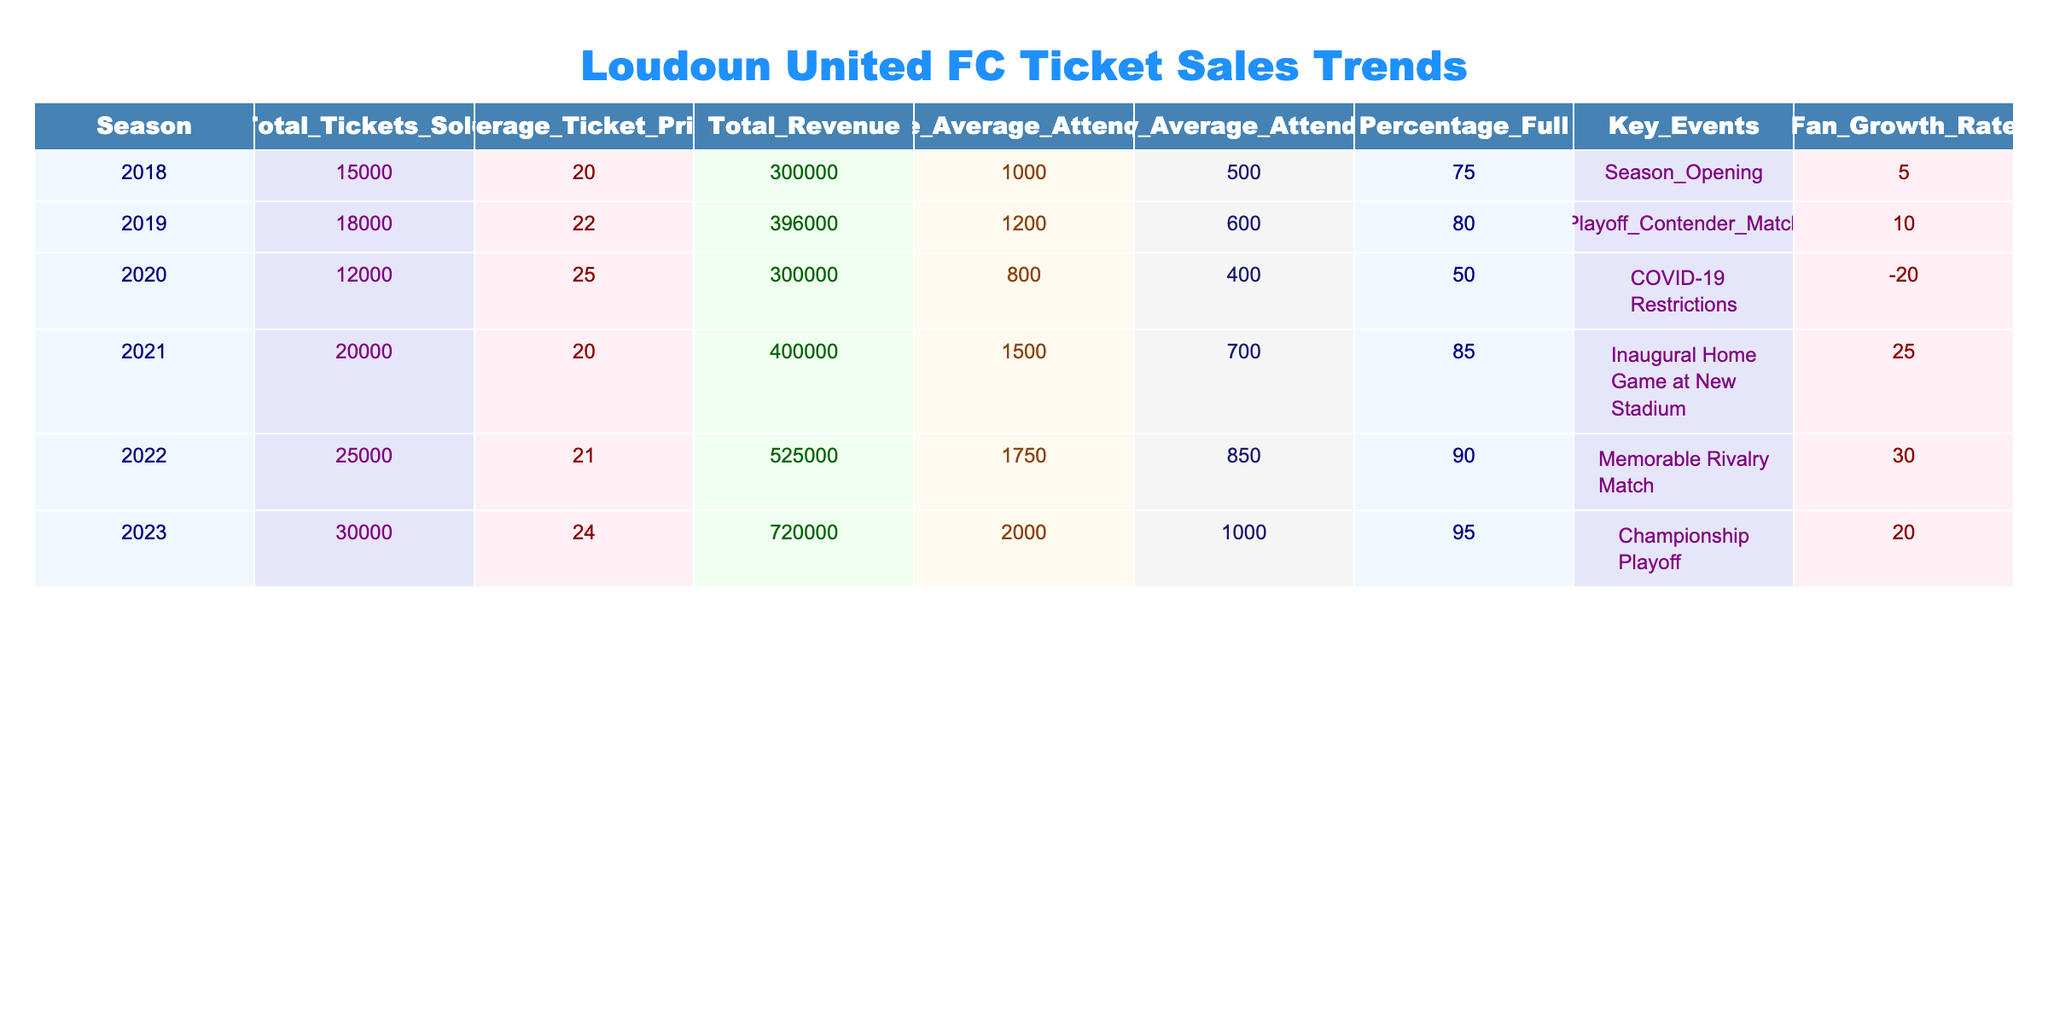What was the total revenue generated in the 2022 season? The total revenue for the 2022 season can be found directly in the table, indicated in the Total_Revenue column for that season. According to the data, the total revenue for 2022 is $525,000.
Answer: 525000 Which season had the highest average ticket price? To identify the season with the highest average ticket price, we need to compare the values in the Average_Ticket_Price column across all seasons. The maximum value is seen in the 2020 season, which is $25.
Answer: 2020 What is the percentage growth rate from the 2018 season to the 2023 season? We need to find the fan growth rate for both the 2018 and 2023 seasons. The growth rate for 2018 is 5, and for 2023 it's 20. To calculate the percentage growth, we subtract the two rates, then divide by the 2018 rate and multiply by 100: (20 - 5) / 5 * 100 = 300%.
Answer: 300% In which season did the average home attendance exceed 1,700? Looking at the Home_Average_Attendance column, we find the seasons where the value exceeds 1,700. Only the 2022 and 2023 seasons have average home attendance above this threshold.
Answer: 2022 and 2023 Did Loudoun United FC see a decline in total ticket sales from 2019 to 2020? By comparing the Total_Tickets_Sold for 2019 (18,000) and 2020 (12,000), we can see that total ticket sales indeed fell from 2019 to 2020, indicating a decline.
Answer: Yes What was the average attendance across all home games for the 2021 season? The Average_Home_Attendance for the 2021 season is directly listed in the table under the Home_Average_Attendance column, which shows that the average attendance was 1,500.
Answer: 1500 What is the total tickets sold for the seasons that had a fan growth rate over 15? We need to identify the seasons with a fan growth rate greater than 15 from the Fan_Growth_Rate column. Those seasons are 2021 (25), 2022 (30), and 2023 (20), which have total tickets sold of 20,000, 25,000, and 30,000 respectively. Adding these gives us: 20000 + 25000 + 30000 = 75000.
Answer: 75000 How many seasons had an average attendance below 1,000? We check the Home_Average_Attendance column for values below 1,000. Only the 2018 season shows an average home attendance of 1,000, and the 2020 season recorded an average of 800, which is below 1,000. Therefore, two seasons qualify.
Answer: 2 